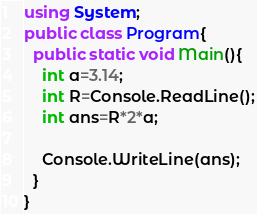Convert code to text. <code><loc_0><loc_0><loc_500><loc_500><_C#_>using System;
public class Program{
  public static void Main(){
    int a=3.14;
    int R=Console.ReadLine();
    int ans=R*2*a;
    
    Console.WriteLine(ans);
  }
}</code> 